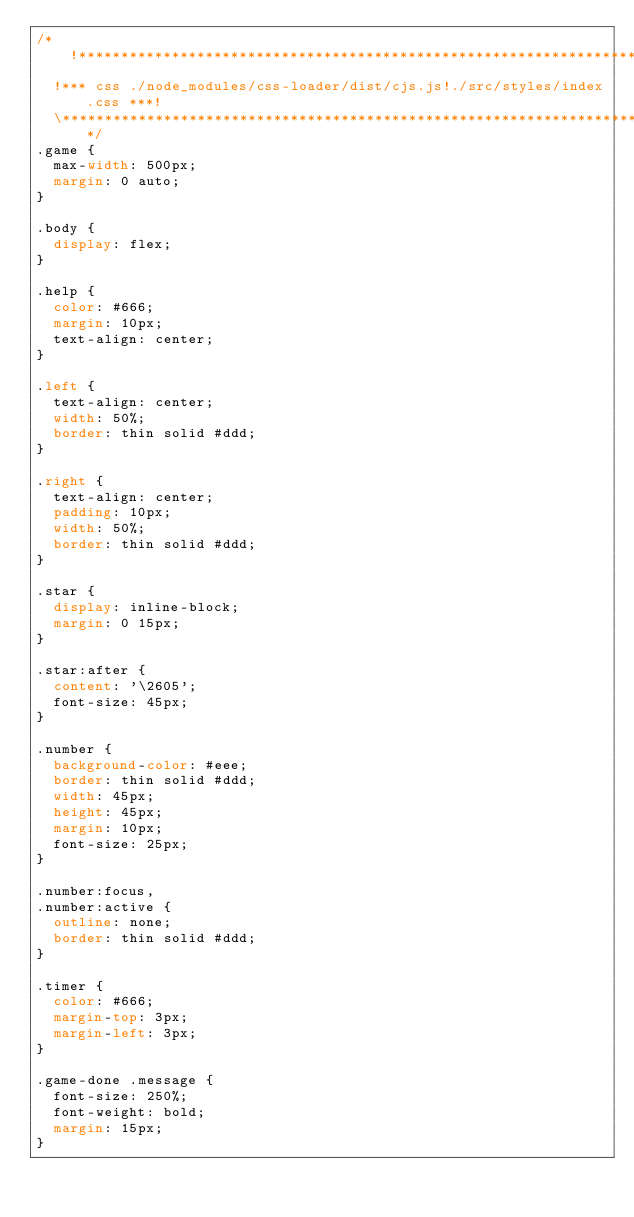Convert code to text. <code><loc_0><loc_0><loc_500><loc_500><_CSS_>/*!************************************************************************!*\
  !*** css ./node_modules/css-loader/dist/cjs.js!./src/styles/index.css ***!
  \************************************************************************/
.game {
  max-width: 500px;
  margin: 0 auto;
}

.body {
  display: flex;
}

.help {
  color: #666;
  margin: 10px;
  text-align: center;
}

.left {
  text-align: center;
  width: 50%;
  border: thin solid #ddd;
}

.right {
  text-align: center;
  padding: 10px;
  width: 50%;
  border: thin solid #ddd;
}

.star {
  display: inline-block;
  margin: 0 15px;
}

.star:after {
  content: '\2605';
  font-size: 45px;
}

.number {
  background-color: #eee;
  border: thin solid #ddd;
  width: 45px;
  height: 45px;
  margin: 10px;
  font-size: 25px;
}

.number:focus,
.number:active {
  outline: none;
  border: thin solid #ddd;
}

.timer {
  color: #666;
  margin-top: 3px;
  margin-left: 3px;
}

.game-done .message {
  font-size: 250%;
  font-weight: bold;
  margin: 15px;
}

</code> 